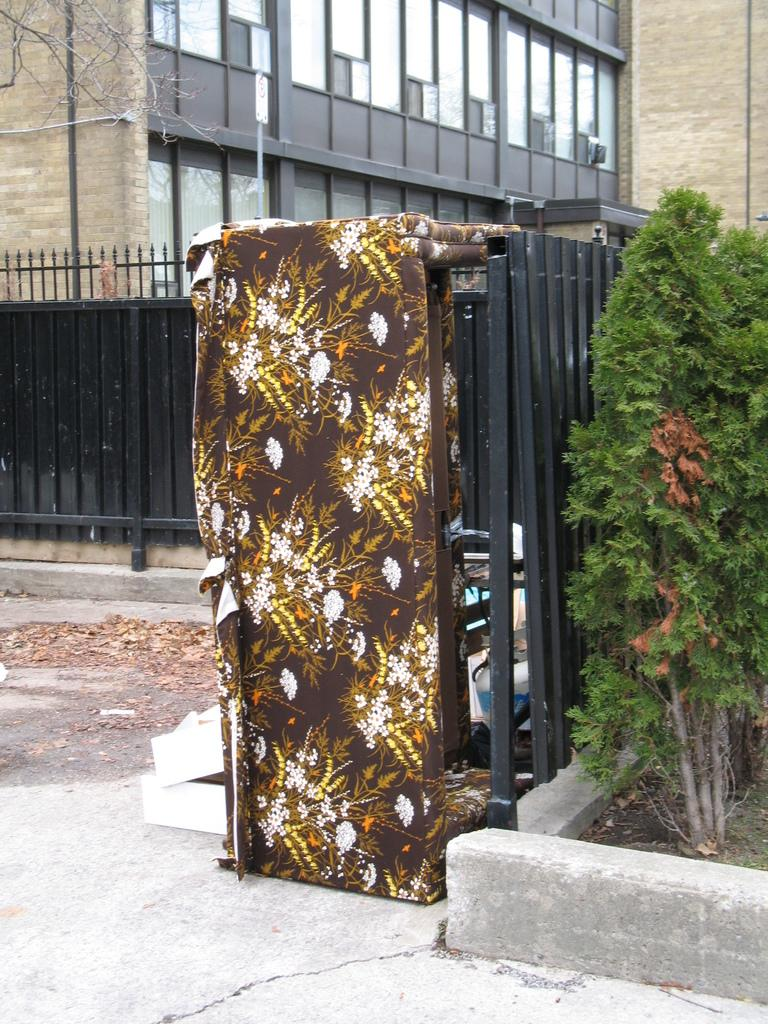What type of fencing is visible in the image? There is black color fencing in the image. What else can be seen in the image besides the fencing? There are plants in the image. What is visible in the background of the image? There is a building in the background of the image. What type of doll can be seen sitting on the fence in the image? There is no doll present in the image; it only features black color fencing and plants. 